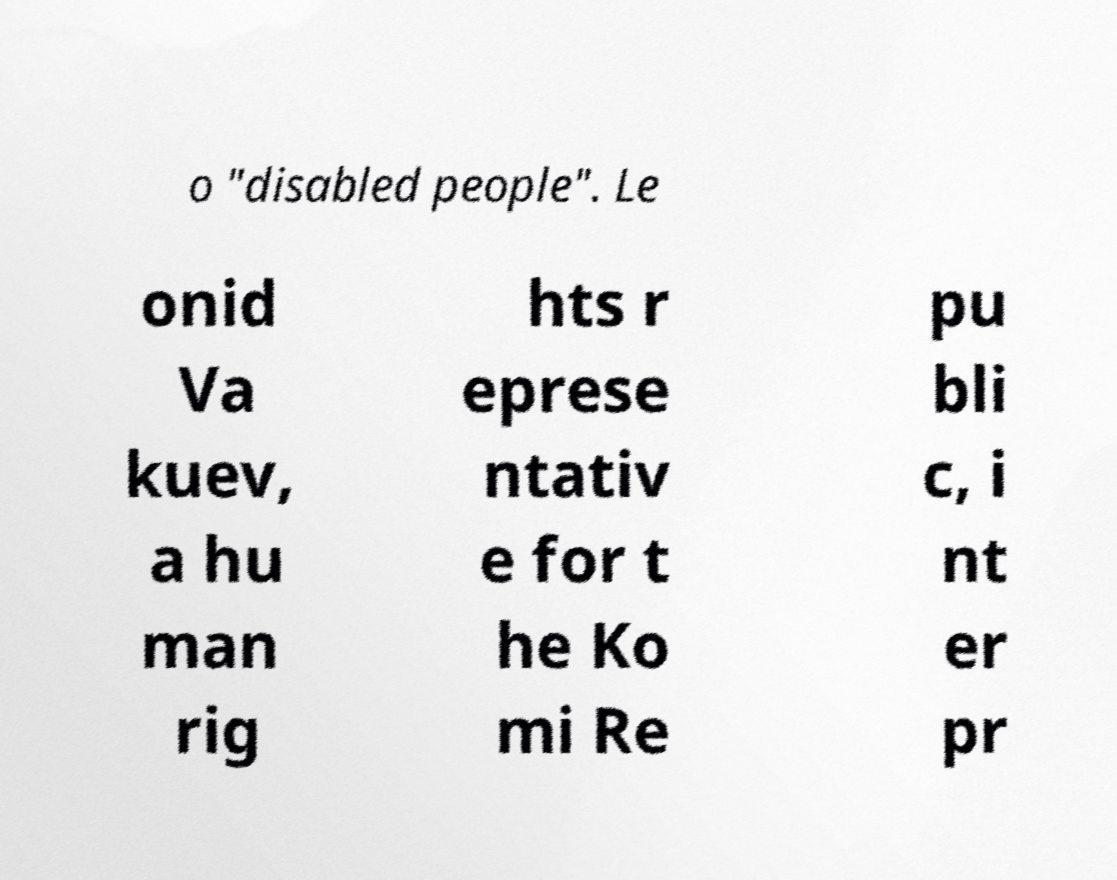I need the written content from this picture converted into text. Can you do that? o "disabled people". Le onid Va kuev, a hu man rig hts r eprese ntativ e for t he Ko mi Re pu bli c, i nt er pr 